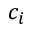Convert formula to latex. <formula><loc_0><loc_0><loc_500><loc_500>c _ { i }</formula> 